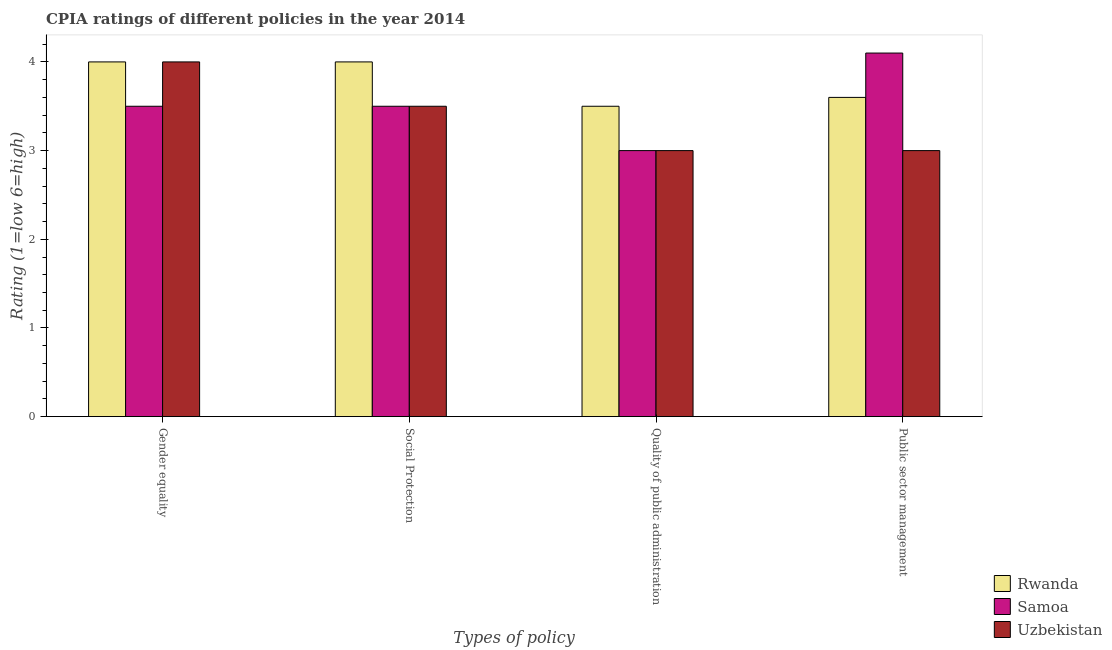How many different coloured bars are there?
Offer a very short reply. 3. What is the label of the 4th group of bars from the left?
Ensure brevity in your answer.  Public sector management. Across all countries, what is the minimum cpia rating of public sector management?
Make the answer very short. 3. In which country was the cpia rating of quality of public administration maximum?
Offer a terse response. Rwanda. In which country was the cpia rating of quality of public administration minimum?
Make the answer very short. Samoa. What is the total cpia rating of quality of public administration in the graph?
Your answer should be very brief. 9.5. What is the difference between the cpia rating of public sector management in Samoa and that in Uzbekistan?
Provide a short and direct response. 1.1. What is the difference between the cpia rating of quality of public administration in Rwanda and the cpia rating of public sector management in Samoa?
Keep it short and to the point. -0.6. What is the average cpia rating of social protection per country?
Give a very brief answer. 3.67. What is the difference between the cpia rating of gender equality and cpia rating of quality of public administration in Samoa?
Keep it short and to the point. 0.5. In how many countries, is the cpia rating of gender equality greater than 1.8 ?
Ensure brevity in your answer.  3. Is the difference between the cpia rating of social protection in Samoa and Uzbekistan greater than the difference between the cpia rating of public sector management in Samoa and Uzbekistan?
Make the answer very short. No. What is the difference between the highest and the second highest cpia rating of quality of public administration?
Ensure brevity in your answer.  0.5. What is the difference between the highest and the lowest cpia rating of gender equality?
Offer a very short reply. 0.5. Is the sum of the cpia rating of social protection in Samoa and Rwanda greater than the maximum cpia rating of gender equality across all countries?
Keep it short and to the point. Yes. Is it the case that in every country, the sum of the cpia rating of quality of public administration and cpia rating of public sector management is greater than the sum of cpia rating of gender equality and cpia rating of social protection?
Provide a short and direct response. No. What does the 3rd bar from the left in Gender equality represents?
Your response must be concise. Uzbekistan. What does the 3rd bar from the right in Social Protection represents?
Your answer should be compact. Rwanda. What is the difference between two consecutive major ticks on the Y-axis?
Provide a succinct answer. 1. Does the graph contain any zero values?
Keep it short and to the point. No. Does the graph contain grids?
Ensure brevity in your answer.  No. Where does the legend appear in the graph?
Your answer should be compact. Bottom right. What is the title of the graph?
Give a very brief answer. CPIA ratings of different policies in the year 2014. What is the label or title of the X-axis?
Your answer should be compact. Types of policy. What is the label or title of the Y-axis?
Offer a very short reply. Rating (1=low 6=high). What is the Rating (1=low 6=high) of Rwanda in Gender equality?
Keep it short and to the point. 4. What is the Rating (1=low 6=high) of Samoa in Gender equality?
Your answer should be very brief. 3.5. What is the Rating (1=low 6=high) of Uzbekistan in Gender equality?
Keep it short and to the point. 4. What is the Rating (1=low 6=high) of Rwanda in Social Protection?
Offer a very short reply. 4. What is the Rating (1=low 6=high) in Samoa in Quality of public administration?
Your response must be concise. 3. What is the Rating (1=low 6=high) in Rwanda in Public sector management?
Ensure brevity in your answer.  3.6. What is the Rating (1=low 6=high) in Samoa in Public sector management?
Provide a succinct answer. 4.1. Across all Types of policy, what is the maximum Rating (1=low 6=high) in Uzbekistan?
Your response must be concise. 4. Across all Types of policy, what is the minimum Rating (1=low 6=high) in Uzbekistan?
Provide a short and direct response. 3. What is the total Rating (1=low 6=high) in Samoa in the graph?
Offer a very short reply. 14.1. What is the difference between the Rating (1=low 6=high) of Rwanda in Gender equality and that in Social Protection?
Provide a succinct answer. 0. What is the difference between the Rating (1=low 6=high) in Rwanda in Gender equality and that in Quality of public administration?
Give a very brief answer. 0.5. What is the difference between the Rating (1=low 6=high) of Rwanda in Gender equality and that in Public sector management?
Your answer should be very brief. 0.4. What is the difference between the Rating (1=low 6=high) of Rwanda in Social Protection and that in Quality of public administration?
Make the answer very short. 0.5. What is the difference between the Rating (1=low 6=high) in Rwanda in Gender equality and the Rating (1=low 6=high) in Samoa in Social Protection?
Give a very brief answer. 0.5. What is the difference between the Rating (1=low 6=high) in Rwanda in Gender equality and the Rating (1=low 6=high) in Samoa in Quality of public administration?
Offer a very short reply. 1. What is the difference between the Rating (1=low 6=high) of Rwanda in Gender equality and the Rating (1=low 6=high) of Uzbekistan in Quality of public administration?
Ensure brevity in your answer.  1. What is the difference between the Rating (1=low 6=high) in Rwanda in Gender equality and the Rating (1=low 6=high) in Samoa in Public sector management?
Give a very brief answer. -0.1. What is the difference between the Rating (1=low 6=high) of Rwanda in Gender equality and the Rating (1=low 6=high) of Uzbekistan in Public sector management?
Offer a terse response. 1. What is the difference between the Rating (1=low 6=high) in Samoa in Social Protection and the Rating (1=low 6=high) in Uzbekistan in Quality of public administration?
Offer a terse response. 0.5. What is the difference between the Rating (1=low 6=high) in Rwanda in Social Protection and the Rating (1=low 6=high) in Samoa in Public sector management?
Keep it short and to the point. -0.1. What is the difference between the Rating (1=low 6=high) of Rwanda in Quality of public administration and the Rating (1=low 6=high) of Uzbekistan in Public sector management?
Make the answer very short. 0.5. What is the difference between the Rating (1=low 6=high) in Samoa in Quality of public administration and the Rating (1=low 6=high) in Uzbekistan in Public sector management?
Offer a terse response. 0. What is the average Rating (1=low 6=high) in Rwanda per Types of policy?
Ensure brevity in your answer.  3.77. What is the average Rating (1=low 6=high) of Samoa per Types of policy?
Ensure brevity in your answer.  3.52. What is the average Rating (1=low 6=high) in Uzbekistan per Types of policy?
Your answer should be compact. 3.38. What is the difference between the Rating (1=low 6=high) in Rwanda and Rating (1=low 6=high) in Samoa in Gender equality?
Give a very brief answer. 0.5. What is the difference between the Rating (1=low 6=high) of Samoa and Rating (1=low 6=high) of Uzbekistan in Gender equality?
Your answer should be compact. -0.5. What is the difference between the Rating (1=low 6=high) of Rwanda and Rating (1=low 6=high) of Samoa in Social Protection?
Provide a short and direct response. 0.5. What is the difference between the Rating (1=low 6=high) of Rwanda and Rating (1=low 6=high) of Uzbekistan in Social Protection?
Offer a terse response. 0.5. What is the difference between the Rating (1=low 6=high) in Samoa and Rating (1=low 6=high) in Uzbekistan in Social Protection?
Your answer should be very brief. 0. What is the difference between the Rating (1=low 6=high) of Rwanda and Rating (1=low 6=high) of Samoa in Public sector management?
Provide a short and direct response. -0.5. What is the difference between the Rating (1=low 6=high) of Rwanda and Rating (1=low 6=high) of Uzbekistan in Public sector management?
Give a very brief answer. 0.6. What is the difference between the Rating (1=low 6=high) in Samoa and Rating (1=low 6=high) in Uzbekistan in Public sector management?
Provide a succinct answer. 1.1. What is the ratio of the Rating (1=low 6=high) in Rwanda in Gender equality to that in Quality of public administration?
Your response must be concise. 1.14. What is the ratio of the Rating (1=low 6=high) in Samoa in Gender equality to that in Quality of public administration?
Offer a very short reply. 1.17. What is the ratio of the Rating (1=low 6=high) of Uzbekistan in Gender equality to that in Quality of public administration?
Your response must be concise. 1.33. What is the ratio of the Rating (1=low 6=high) of Rwanda in Gender equality to that in Public sector management?
Offer a terse response. 1.11. What is the ratio of the Rating (1=low 6=high) of Samoa in Gender equality to that in Public sector management?
Ensure brevity in your answer.  0.85. What is the ratio of the Rating (1=low 6=high) of Samoa in Social Protection to that in Quality of public administration?
Your answer should be very brief. 1.17. What is the ratio of the Rating (1=low 6=high) of Uzbekistan in Social Protection to that in Quality of public administration?
Give a very brief answer. 1.17. What is the ratio of the Rating (1=low 6=high) in Samoa in Social Protection to that in Public sector management?
Your response must be concise. 0.85. What is the ratio of the Rating (1=low 6=high) in Rwanda in Quality of public administration to that in Public sector management?
Give a very brief answer. 0.97. What is the ratio of the Rating (1=low 6=high) of Samoa in Quality of public administration to that in Public sector management?
Offer a terse response. 0.73. What is the difference between the highest and the second highest Rating (1=low 6=high) of Rwanda?
Offer a terse response. 0. What is the difference between the highest and the second highest Rating (1=low 6=high) in Samoa?
Make the answer very short. 0.6. What is the difference between the highest and the second highest Rating (1=low 6=high) of Uzbekistan?
Keep it short and to the point. 0.5. What is the difference between the highest and the lowest Rating (1=low 6=high) in Rwanda?
Your answer should be compact. 0.5. What is the difference between the highest and the lowest Rating (1=low 6=high) in Samoa?
Your answer should be compact. 1.1. 